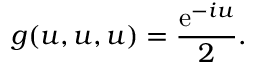<formula> <loc_0><loc_0><loc_500><loc_500>g ( u , u , u ) = \frac { e ^ { - i u } } { 2 } .</formula> 